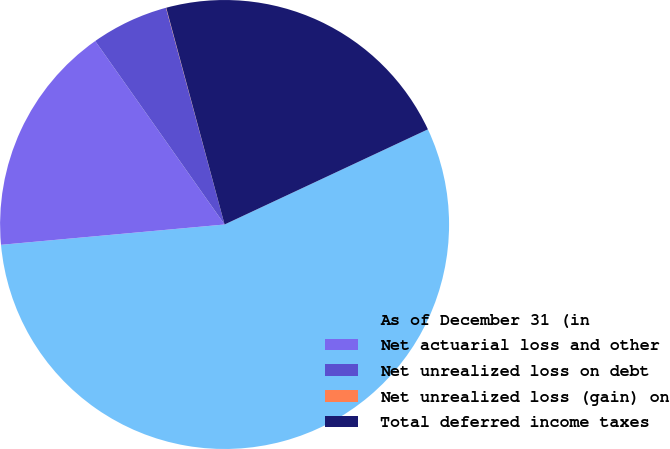Convert chart to OTSL. <chart><loc_0><loc_0><loc_500><loc_500><pie_chart><fcel>As of December 31 (in<fcel>Net actuarial loss and other<fcel>Net unrealized loss on debt<fcel>Net unrealized loss (gain) on<fcel>Total deferred income taxes<nl><fcel>55.53%<fcel>16.67%<fcel>5.57%<fcel>0.02%<fcel>22.22%<nl></chart> 